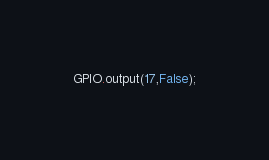Convert code to text. <code><loc_0><loc_0><loc_500><loc_500><_Python_>GPIO.output(17,False);
</code> 